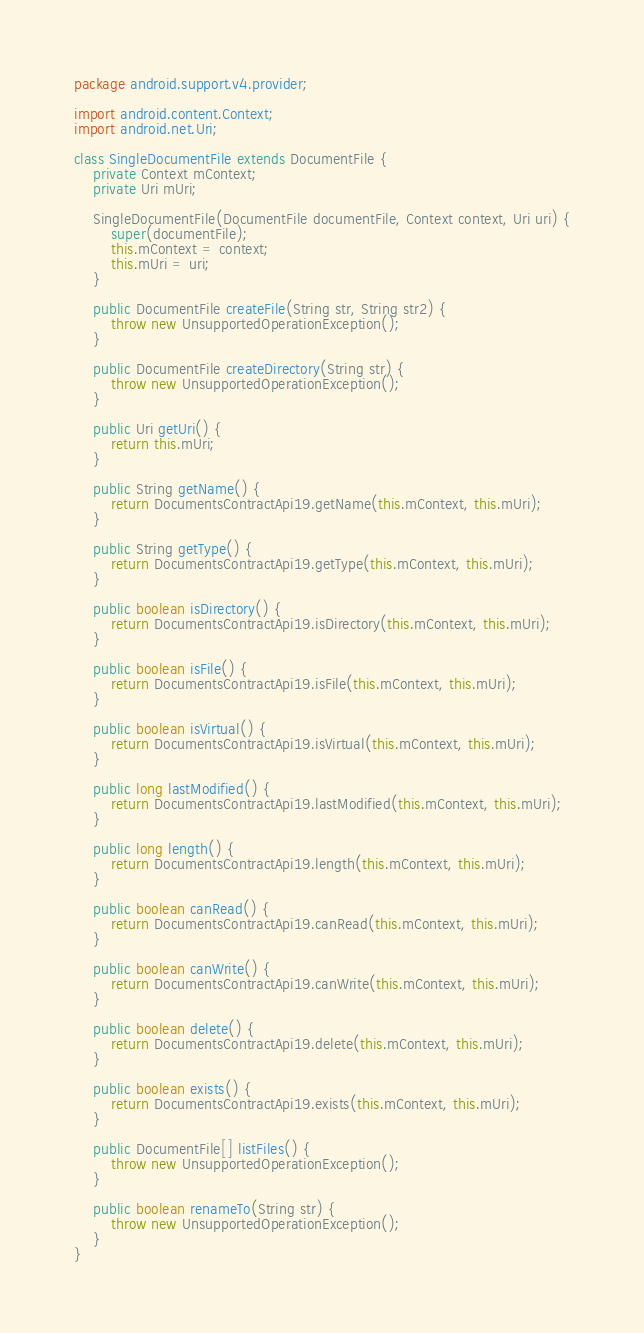<code> <loc_0><loc_0><loc_500><loc_500><_Java_>package android.support.v4.provider;

import android.content.Context;
import android.net.Uri;

class SingleDocumentFile extends DocumentFile {
    private Context mContext;
    private Uri mUri;

    SingleDocumentFile(DocumentFile documentFile, Context context, Uri uri) {
        super(documentFile);
        this.mContext = context;
        this.mUri = uri;
    }

    public DocumentFile createFile(String str, String str2) {
        throw new UnsupportedOperationException();
    }

    public DocumentFile createDirectory(String str) {
        throw new UnsupportedOperationException();
    }

    public Uri getUri() {
        return this.mUri;
    }

    public String getName() {
        return DocumentsContractApi19.getName(this.mContext, this.mUri);
    }

    public String getType() {
        return DocumentsContractApi19.getType(this.mContext, this.mUri);
    }

    public boolean isDirectory() {
        return DocumentsContractApi19.isDirectory(this.mContext, this.mUri);
    }

    public boolean isFile() {
        return DocumentsContractApi19.isFile(this.mContext, this.mUri);
    }

    public boolean isVirtual() {
        return DocumentsContractApi19.isVirtual(this.mContext, this.mUri);
    }

    public long lastModified() {
        return DocumentsContractApi19.lastModified(this.mContext, this.mUri);
    }

    public long length() {
        return DocumentsContractApi19.length(this.mContext, this.mUri);
    }

    public boolean canRead() {
        return DocumentsContractApi19.canRead(this.mContext, this.mUri);
    }

    public boolean canWrite() {
        return DocumentsContractApi19.canWrite(this.mContext, this.mUri);
    }

    public boolean delete() {
        return DocumentsContractApi19.delete(this.mContext, this.mUri);
    }

    public boolean exists() {
        return DocumentsContractApi19.exists(this.mContext, this.mUri);
    }

    public DocumentFile[] listFiles() {
        throw new UnsupportedOperationException();
    }

    public boolean renameTo(String str) {
        throw new UnsupportedOperationException();
    }
}
</code> 